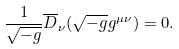<formula> <loc_0><loc_0><loc_500><loc_500>\frac { 1 } { \sqrt { - g } } \overline { D } _ { \nu } ( \sqrt { - g } g ^ { \mu \nu } ) = 0 .</formula> 